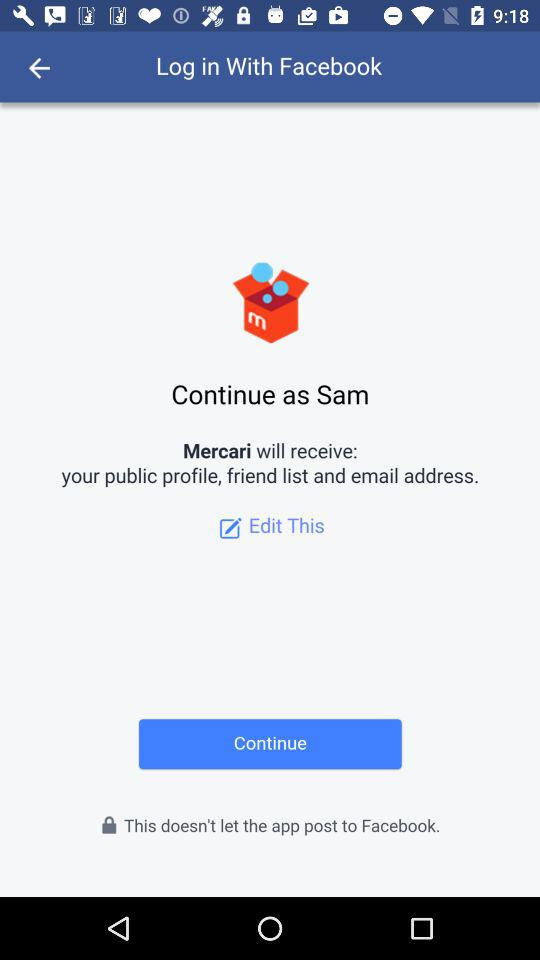What is the user name? The user name is Sam. 